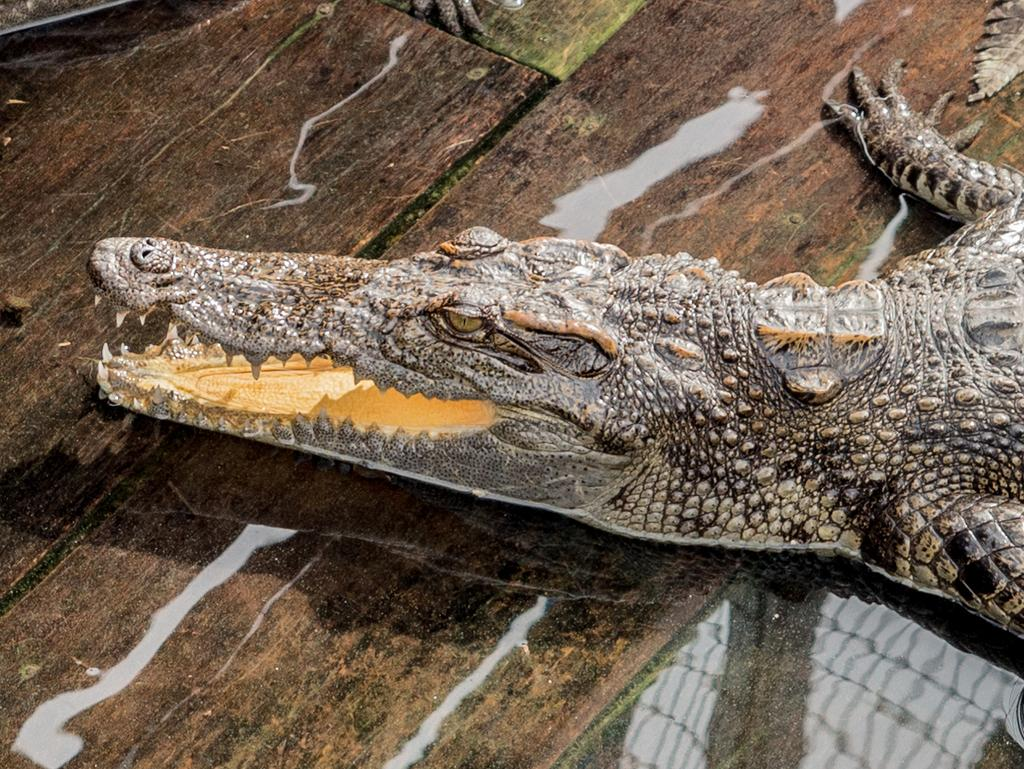What is the main subject in the center of the image? There is a crocodile in the center of the image. What type of tool is the crocodile using to mix the eggnog in the image? There is no eggnog or tool present in the image; it features a crocodile as the main subject. 